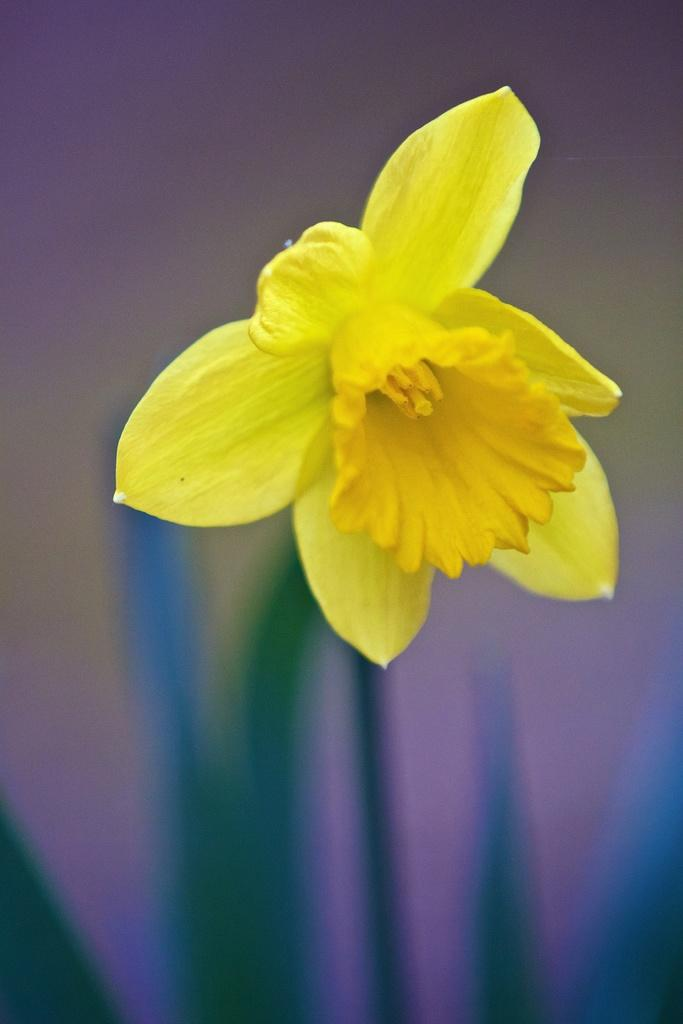What type of flower is in the picture? There is a yellow flower in the picture. What color is the background of the flower? The background of the flower is blue. What type of ink is used to draw the flower in the image? There is no information about the ink used to draw the flower in the image, as it is a photograph of a real flower. 